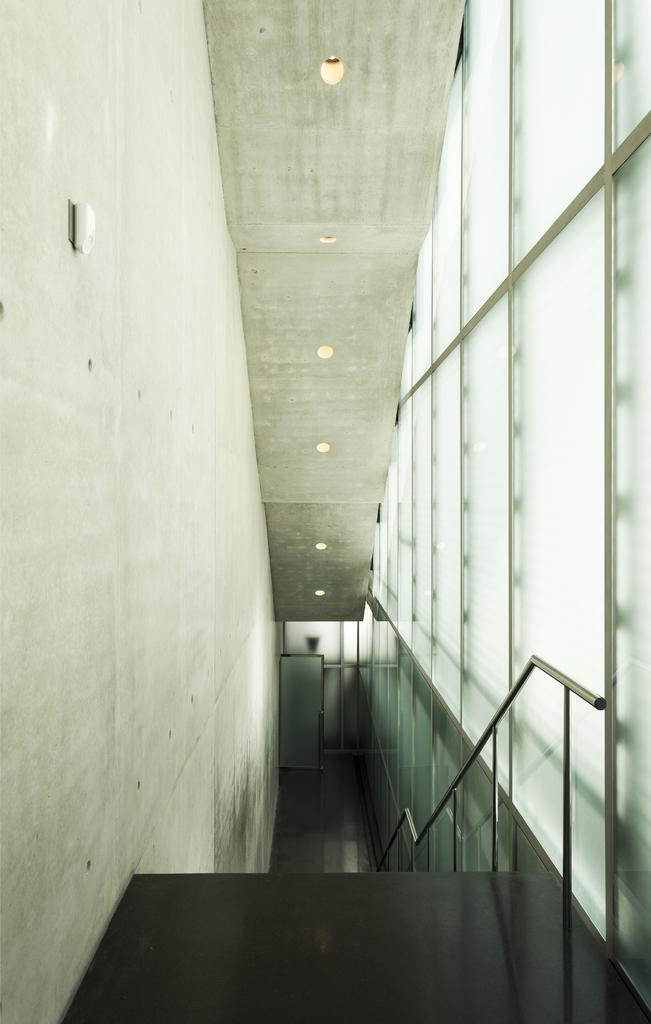What type of architectural feature is present in the image? There are stairs in the image. What other structural elements can be seen in the image? There is a wall and a door in the center of the image. What is located at the top of the image? There are lights at the top of the image. Is there any safety feature visible in the image? Yes, there is a railing visible in the image. What object is on the right side of the image? There is a glass on the right side of the image. What type of pie is being served on the quartz countertop in the image? There is no pie or quartz countertop present in the image. 